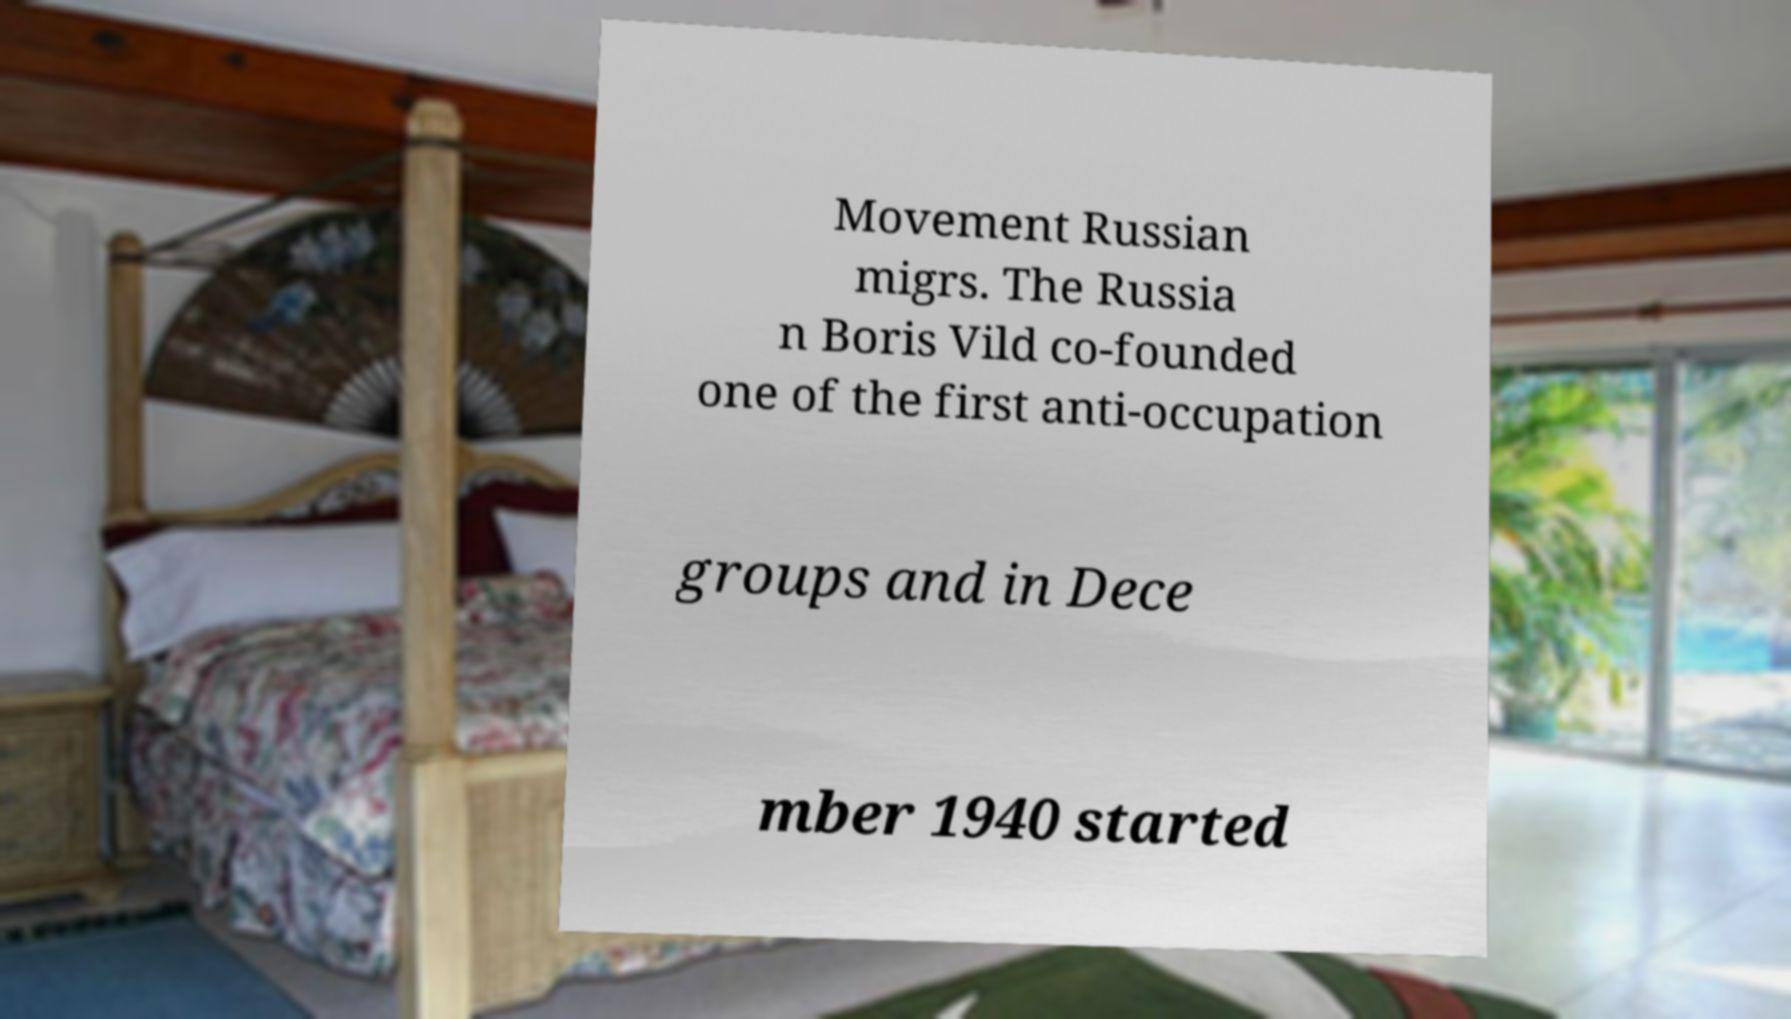Could you extract and type out the text from this image? Movement Russian migrs. The Russia n Boris Vild co-founded one of the first anti-occupation groups and in Dece mber 1940 started 